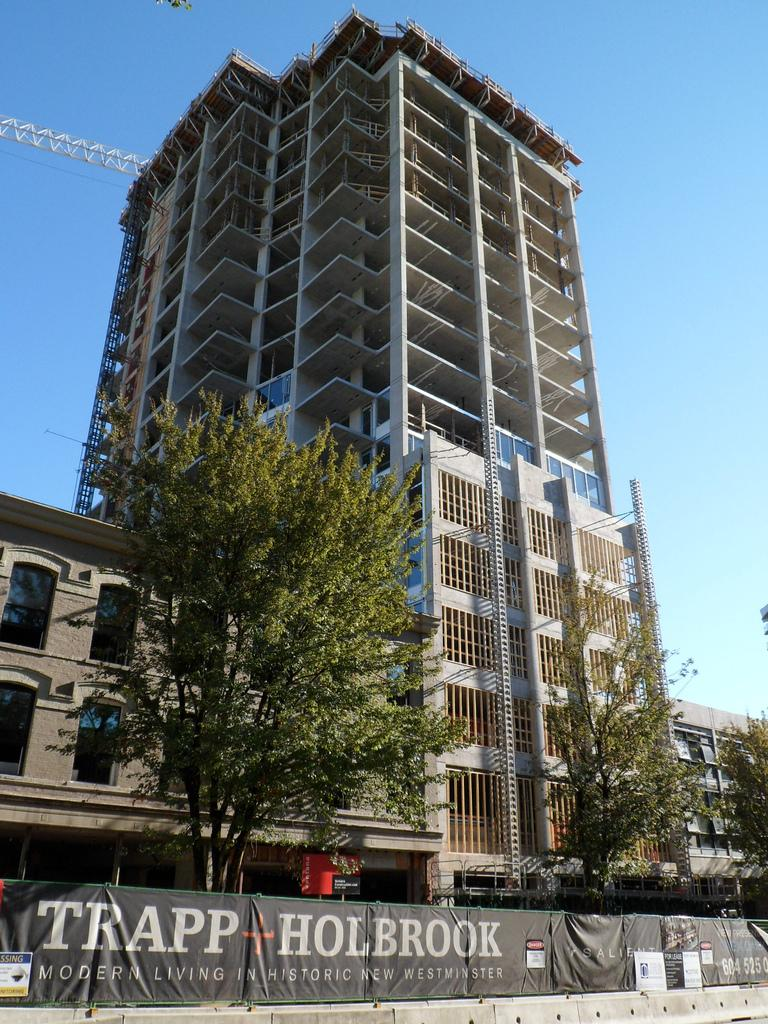What type of structures can be seen in the image? There are buildings in the image. What other natural elements are present in the image? There are trees in the image. What type of signage is visible in the image? There is an advertisement board in the image. What construction equipment can be seen in the image? There is a construction crane in the image. What can be seen in the background of the image? The sky is visible in the background of the image. What type of crib is visible in the image? There is no crib present in the image. What sign is displayed on the construction crane in the image? The construction crane in the image does not have a sign; it is a piece of equipment used for lifting and moving heavy objects. 